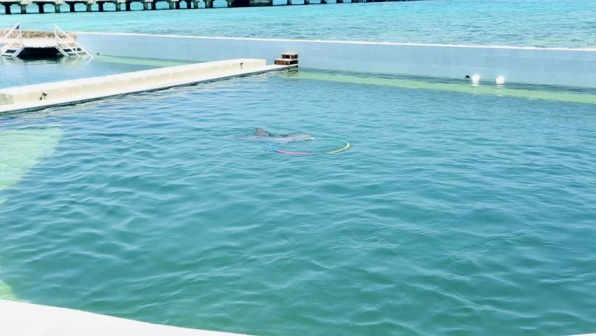What is this photo about? The image showcases a peaceful setting of a dolphin swimming in a large, tranquil pool. The dolphin, identifiable by its signature gray color, is near the surface of the clear, blue-green water. This serene environment is bordered by white and gray concrete walls that frame the scene and add a sense of depth.

In the background, there is a long, brown wooden pier reaching into the waters, at the end of which stands a small, white building with a brown roof. This structure serves as a focal point in the background and hints at the human presence in this natural setting.

Additionally, two white buoys float close to the pier, their bright color standing out against the blue-green water, indicating navigational or safety measures in place. Overall, the image offers a calming depiction of a dolphin in a peacefully contained aquatic environment, intertwined subtly with human-made structures. 